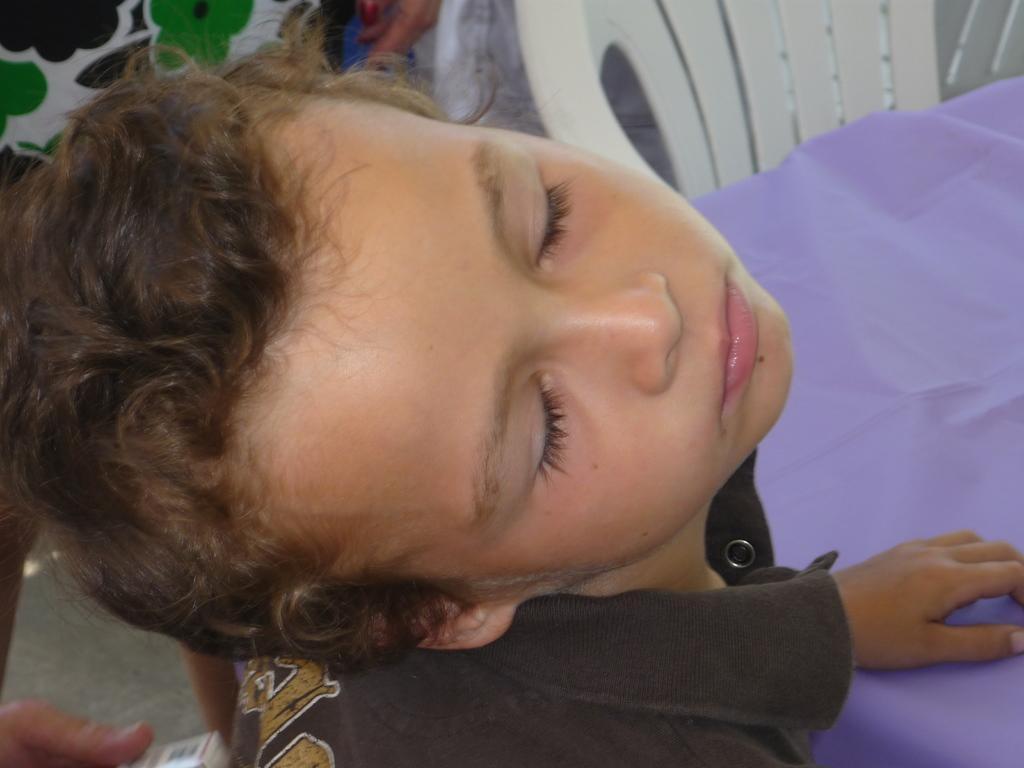Could you give a brief overview of what you see in this image? This picture shows a boy closing his eyes and he wore a black shirt and we see a chair and a table and we see couple of human hands on the side. 